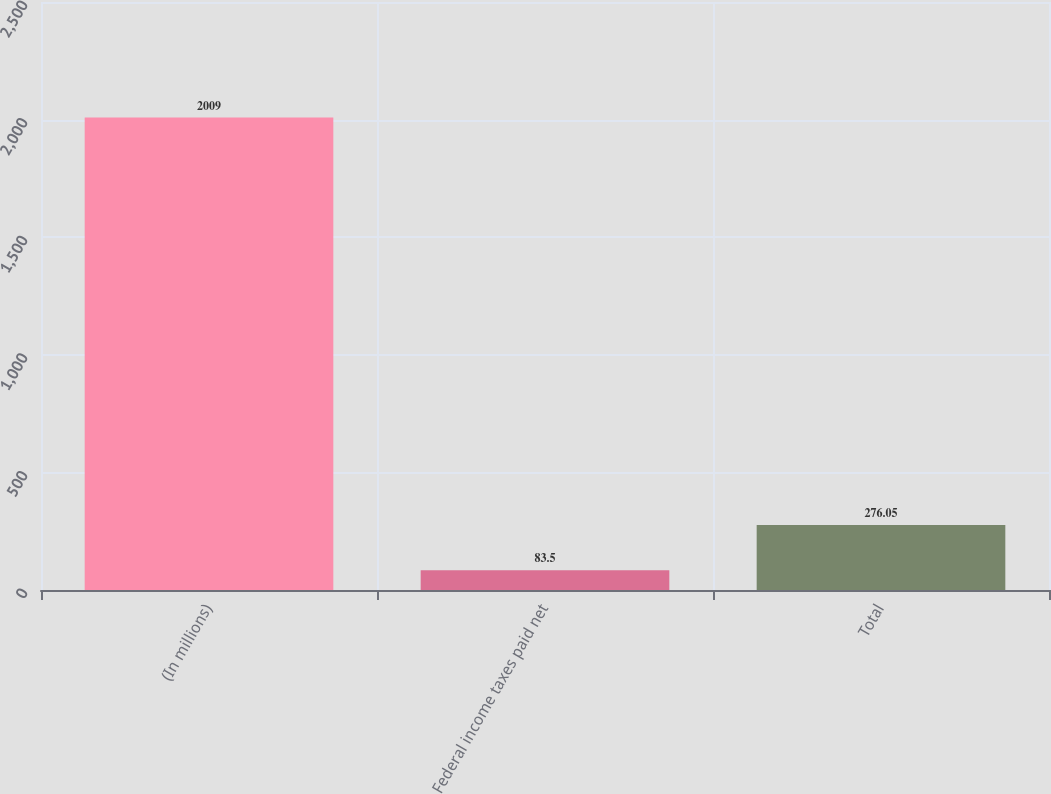Convert chart. <chart><loc_0><loc_0><loc_500><loc_500><bar_chart><fcel>(In millions)<fcel>Federal income taxes paid net<fcel>Total<nl><fcel>2009<fcel>83.5<fcel>276.05<nl></chart> 